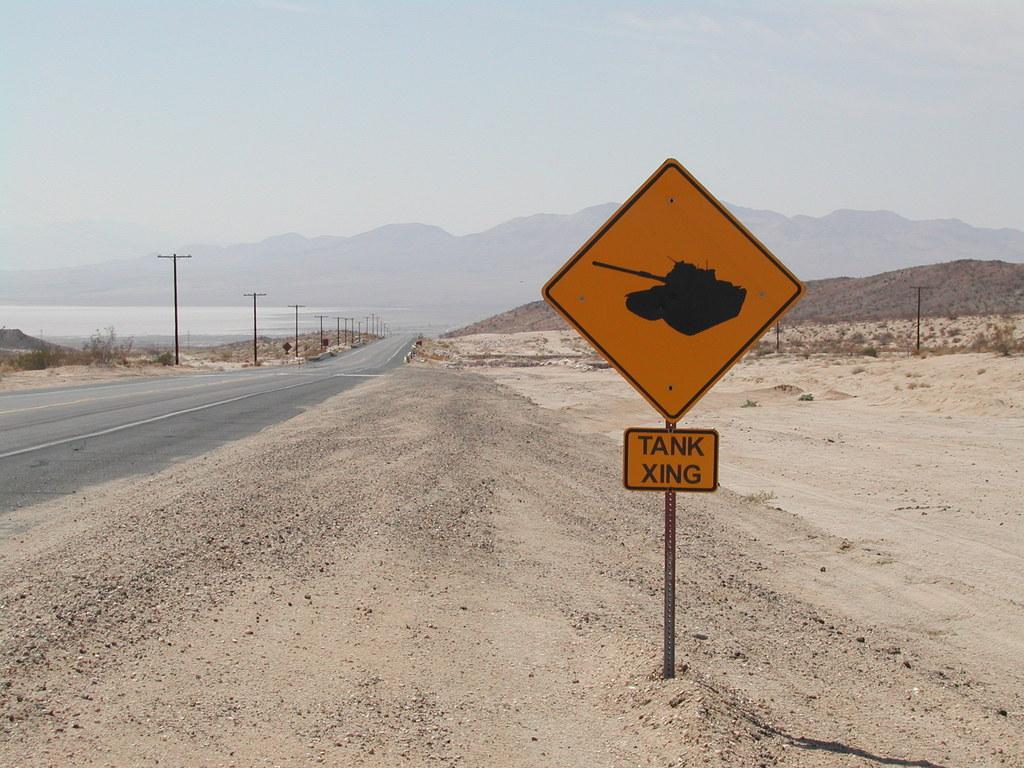What might someone expect to see crossing the road in this area?
Your answer should be very brief. Tank. How is crossing spelled in the photo?
Your answer should be compact. Xing. 